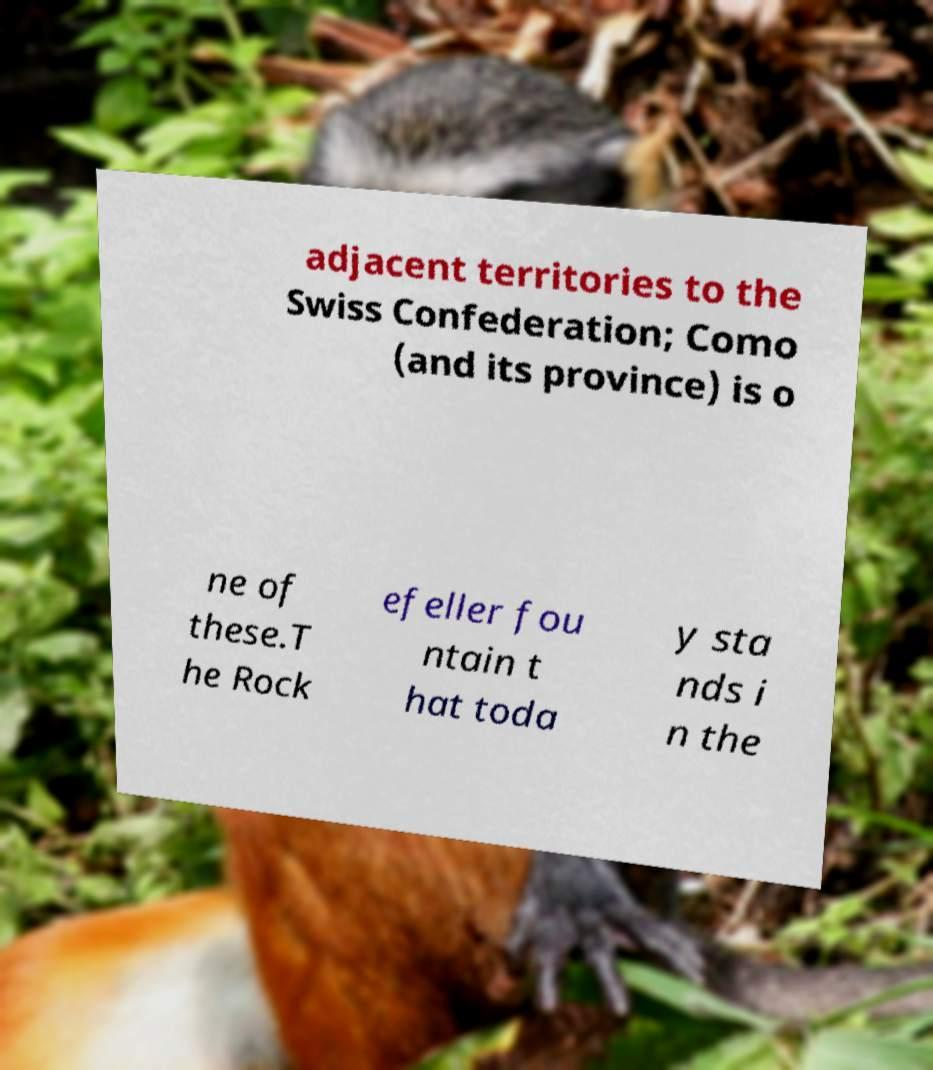Please identify and transcribe the text found in this image. adjacent territories to the Swiss Confederation; Como (and its province) is o ne of these.T he Rock efeller fou ntain t hat toda y sta nds i n the 